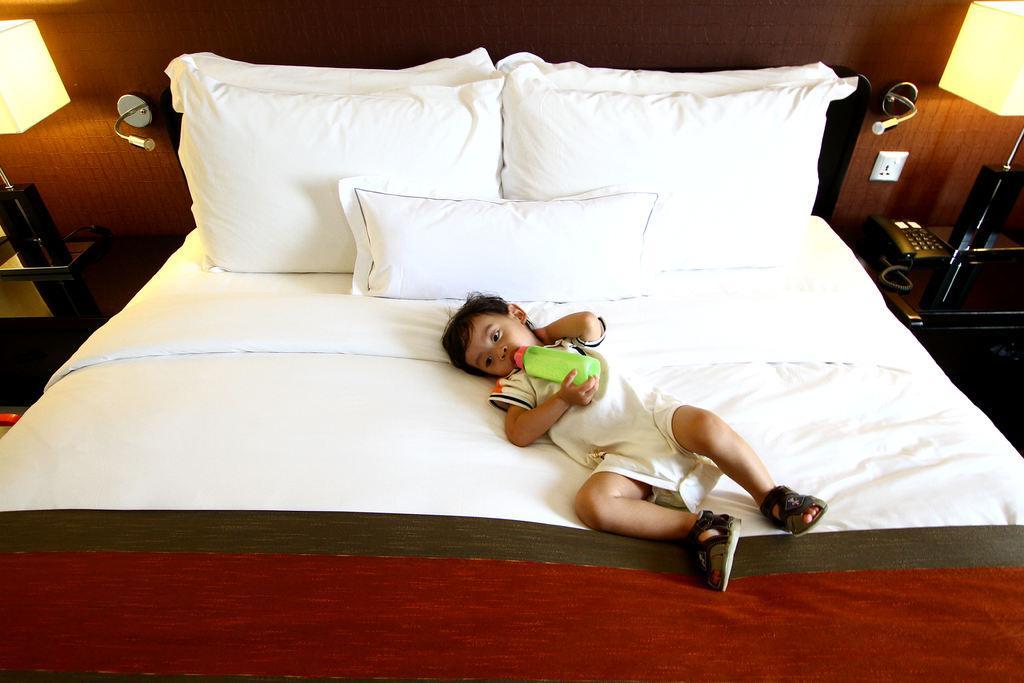Can you describe this image briefly? This picture is taken in a room. There is a kid holding a bottle and he is lying on the bed. There are 3 pillows on the bed. Towards the left there is a lamp. Towards the right there is a lamp, switch board and a telephone. 